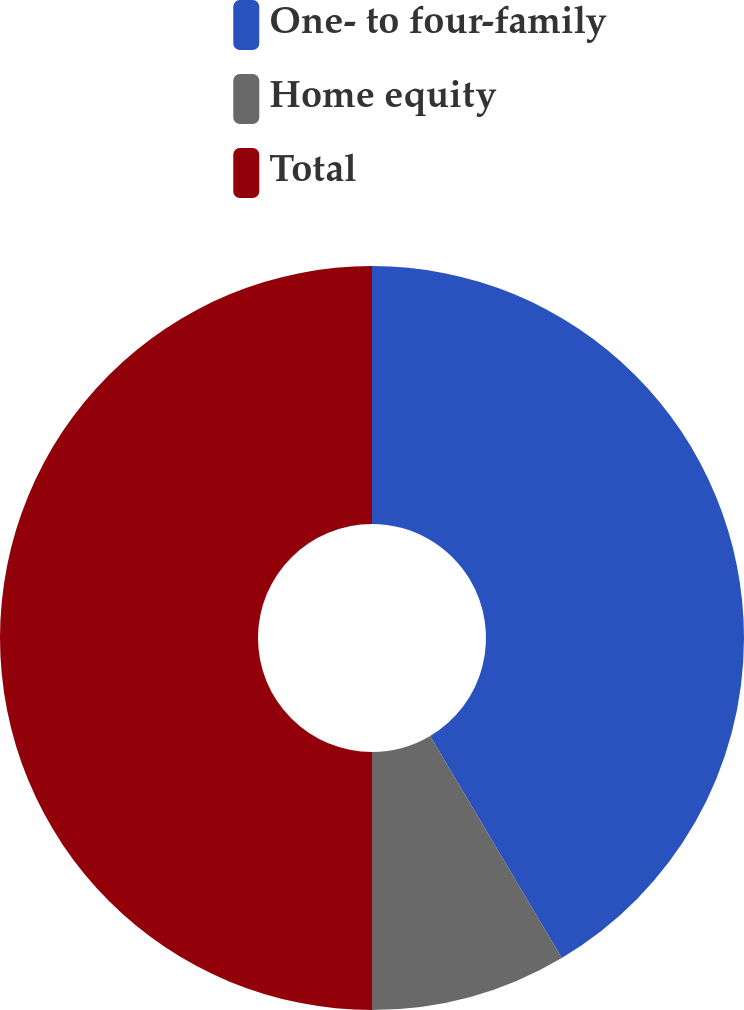Convert chart. <chart><loc_0><loc_0><loc_500><loc_500><pie_chart><fcel>One- to four-family<fcel>Home equity<fcel>Total<nl><fcel>41.48%<fcel>8.52%<fcel>50.0%<nl></chart> 